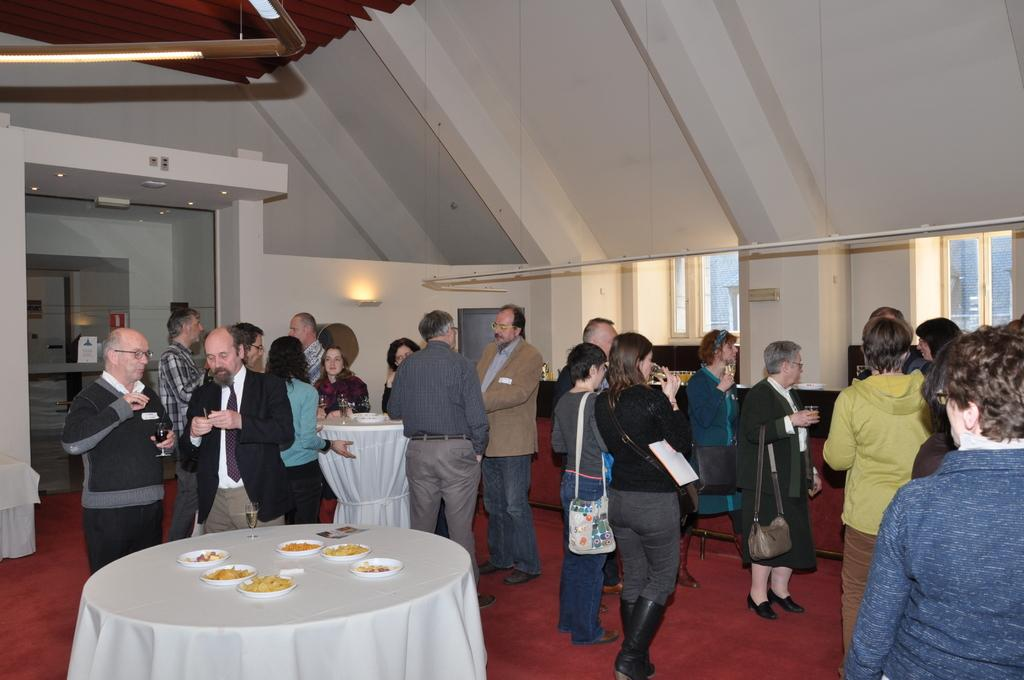How many people are in the image? There are many people in the image. What is the surface that the people are standing on? The people are standing on a red carpet. What type of event might be taking place in the image? The setting appears to be a party. Can you describe any objects related to food or refreshments in the image? There is a table with food in the image. What instrument does the fireman play at the party in the image? There is no fireman or instrument present in the image. 